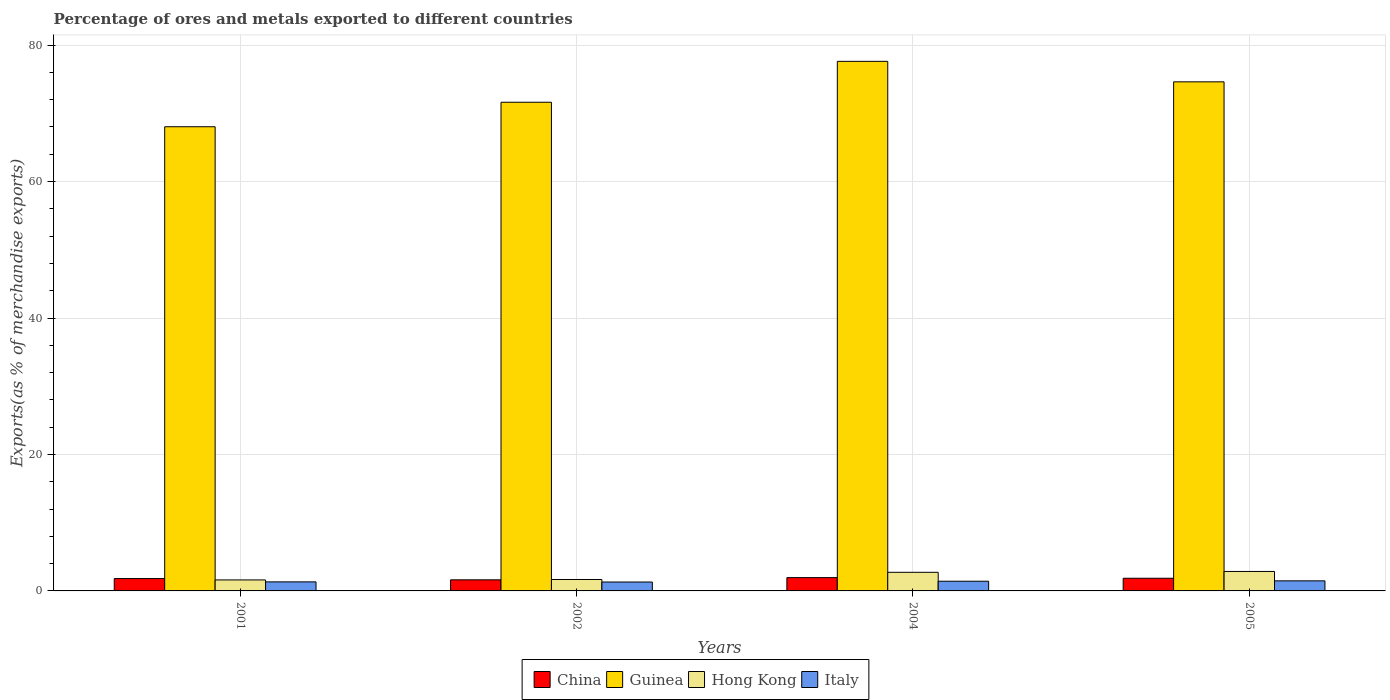How many groups of bars are there?
Offer a terse response. 4. Are the number of bars per tick equal to the number of legend labels?
Your response must be concise. Yes. Are the number of bars on each tick of the X-axis equal?
Make the answer very short. Yes. How many bars are there on the 2nd tick from the right?
Provide a succinct answer. 4. What is the label of the 2nd group of bars from the left?
Give a very brief answer. 2002. What is the percentage of exports to different countries in Guinea in 2004?
Your answer should be very brief. 77.62. Across all years, what is the maximum percentage of exports to different countries in Guinea?
Your answer should be very brief. 77.62. Across all years, what is the minimum percentage of exports to different countries in Italy?
Make the answer very short. 1.3. In which year was the percentage of exports to different countries in China maximum?
Keep it short and to the point. 2004. What is the total percentage of exports to different countries in China in the graph?
Make the answer very short. 7.24. What is the difference between the percentage of exports to different countries in Hong Kong in 2002 and that in 2004?
Provide a short and direct response. -1.05. What is the difference between the percentage of exports to different countries in China in 2001 and the percentage of exports to different countries in Guinea in 2004?
Keep it short and to the point. -75.81. What is the average percentage of exports to different countries in Italy per year?
Give a very brief answer. 1.38. In the year 2005, what is the difference between the percentage of exports to different countries in Hong Kong and percentage of exports to different countries in Guinea?
Your answer should be very brief. -71.76. What is the ratio of the percentage of exports to different countries in Hong Kong in 2001 to that in 2004?
Give a very brief answer. 0.59. What is the difference between the highest and the second highest percentage of exports to different countries in Hong Kong?
Provide a succinct answer. 0.12. What is the difference between the highest and the lowest percentage of exports to different countries in China?
Ensure brevity in your answer.  0.32. Is the sum of the percentage of exports to different countries in Italy in 2004 and 2005 greater than the maximum percentage of exports to different countries in China across all years?
Give a very brief answer. Yes. What does the 1st bar from the right in 2005 represents?
Offer a very short reply. Italy. How many years are there in the graph?
Offer a very short reply. 4. What is the difference between two consecutive major ticks on the Y-axis?
Your answer should be very brief. 20. Does the graph contain any zero values?
Provide a succinct answer. No. Does the graph contain grids?
Provide a succinct answer. Yes. How many legend labels are there?
Offer a very short reply. 4. What is the title of the graph?
Provide a succinct answer. Percentage of ores and metals exported to different countries. Does "Lesotho" appear as one of the legend labels in the graph?
Your response must be concise. No. What is the label or title of the X-axis?
Keep it short and to the point. Years. What is the label or title of the Y-axis?
Make the answer very short. Exports(as % of merchandise exports). What is the Exports(as % of merchandise exports) of China in 2001?
Keep it short and to the point. 1.81. What is the Exports(as % of merchandise exports) in Guinea in 2001?
Your answer should be very brief. 68.03. What is the Exports(as % of merchandise exports) in Hong Kong in 2001?
Keep it short and to the point. 1.61. What is the Exports(as % of merchandise exports) of Italy in 2001?
Offer a terse response. 1.32. What is the Exports(as % of merchandise exports) of China in 2002?
Offer a very short reply. 1.62. What is the Exports(as % of merchandise exports) in Guinea in 2002?
Your response must be concise. 71.63. What is the Exports(as % of merchandise exports) in Hong Kong in 2002?
Your answer should be compact. 1.67. What is the Exports(as % of merchandise exports) of Italy in 2002?
Your answer should be very brief. 1.3. What is the Exports(as % of merchandise exports) of China in 2004?
Your answer should be very brief. 1.95. What is the Exports(as % of merchandise exports) of Guinea in 2004?
Keep it short and to the point. 77.62. What is the Exports(as % of merchandise exports) of Hong Kong in 2004?
Your answer should be very brief. 2.73. What is the Exports(as % of merchandise exports) of Italy in 2004?
Ensure brevity in your answer.  1.42. What is the Exports(as % of merchandise exports) in China in 2005?
Keep it short and to the point. 1.86. What is the Exports(as % of merchandise exports) of Guinea in 2005?
Offer a very short reply. 74.62. What is the Exports(as % of merchandise exports) in Hong Kong in 2005?
Your answer should be compact. 2.85. What is the Exports(as % of merchandise exports) of Italy in 2005?
Ensure brevity in your answer.  1.48. Across all years, what is the maximum Exports(as % of merchandise exports) in China?
Keep it short and to the point. 1.95. Across all years, what is the maximum Exports(as % of merchandise exports) of Guinea?
Your answer should be very brief. 77.62. Across all years, what is the maximum Exports(as % of merchandise exports) of Hong Kong?
Make the answer very short. 2.85. Across all years, what is the maximum Exports(as % of merchandise exports) of Italy?
Provide a short and direct response. 1.48. Across all years, what is the minimum Exports(as % of merchandise exports) in China?
Make the answer very short. 1.62. Across all years, what is the minimum Exports(as % of merchandise exports) of Guinea?
Your answer should be very brief. 68.03. Across all years, what is the minimum Exports(as % of merchandise exports) in Hong Kong?
Your answer should be very brief. 1.61. Across all years, what is the minimum Exports(as % of merchandise exports) in Italy?
Your answer should be compact. 1.3. What is the total Exports(as % of merchandise exports) in China in the graph?
Your answer should be very brief. 7.24. What is the total Exports(as % of merchandise exports) of Guinea in the graph?
Your answer should be very brief. 291.9. What is the total Exports(as % of merchandise exports) in Hong Kong in the graph?
Ensure brevity in your answer.  8.87. What is the total Exports(as % of merchandise exports) of Italy in the graph?
Your answer should be compact. 5.52. What is the difference between the Exports(as % of merchandise exports) of China in 2001 and that in 2002?
Give a very brief answer. 0.19. What is the difference between the Exports(as % of merchandise exports) of Guinea in 2001 and that in 2002?
Make the answer very short. -3.59. What is the difference between the Exports(as % of merchandise exports) of Hong Kong in 2001 and that in 2002?
Offer a terse response. -0.06. What is the difference between the Exports(as % of merchandise exports) of Italy in 2001 and that in 2002?
Provide a short and direct response. 0.02. What is the difference between the Exports(as % of merchandise exports) in China in 2001 and that in 2004?
Keep it short and to the point. -0.14. What is the difference between the Exports(as % of merchandise exports) of Guinea in 2001 and that in 2004?
Provide a short and direct response. -9.58. What is the difference between the Exports(as % of merchandise exports) of Hong Kong in 2001 and that in 2004?
Make the answer very short. -1.12. What is the difference between the Exports(as % of merchandise exports) of Italy in 2001 and that in 2004?
Ensure brevity in your answer.  -0.1. What is the difference between the Exports(as % of merchandise exports) in China in 2001 and that in 2005?
Keep it short and to the point. -0.05. What is the difference between the Exports(as % of merchandise exports) of Guinea in 2001 and that in 2005?
Provide a short and direct response. -6.58. What is the difference between the Exports(as % of merchandise exports) in Hong Kong in 2001 and that in 2005?
Offer a terse response. -1.24. What is the difference between the Exports(as % of merchandise exports) of Italy in 2001 and that in 2005?
Offer a very short reply. -0.15. What is the difference between the Exports(as % of merchandise exports) of China in 2002 and that in 2004?
Your answer should be compact. -0.32. What is the difference between the Exports(as % of merchandise exports) of Guinea in 2002 and that in 2004?
Provide a succinct answer. -5.99. What is the difference between the Exports(as % of merchandise exports) of Hong Kong in 2002 and that in 2004?
Ensure brevity in your answer.  -1.05. What is the difference between the Exports(as % of merchandise exports) of Italy in 2002 and that in 2004?
Keep it short and to the point. -0.12. What is the difference between the Exports(as % of merchandise exports) of China in 2002 and that in 2005?
Provide a succinct answer. -0.23. What is the difference between the Exports(as % of merchandise exports) of Guinea in 2002 and that in 2005?
Your response must be concise. -2.99. What is the difference between the Exports(as % of merchandise exports) of Hong Kong in 2002 and that in 2005?
Give a very brief answer. -1.18. What is the difference between the Exports(as % of merchandise exports) in Italy in 2002 and that in 2005?
Provide a short and direct response. -0.17. What is the difference between the Exports(as % of merchandise exports) of China in 2004 and that in 2005?
Provide a short and direct response. 0.09. What is the difference between the Exports(as % of merchandise exports) of Guinea in 2004 and that in 2005?
Your answer should be compact. 3. What is the difference between the Exports(as % of merchandise exports) in Hong Kong in 2004 and that in 2005?
Offer a terse response. -0.12. What is the difference between the Exports(as % of merchandise exports) in Italy in 2004 and that in 2005?
Keep it short and to the point. -0.05. What is the difference between the Exports(as % of merchandise exports) of China in 2001 and the Exports(as % of merchandise exports) of Guinea in 2002?
Ensure brevity in your answer.  -69.82. What is the difference between the Exports(as % of merchandise exports) of China in 2001 and the Exports(as % of merchandise exports) of Hong Kong in 2002?
Keep it short and to the point. 0.14. What is the difference between the Exports(as % of merchandise exports) of China in 2001 and the Exports(as % of merchandise exports) of Italy in 2002?
Provide a succinct answer. 0.51. What is the difference between the Exports(as % of merchandise exports) of Guinea in 2001 and the Exports(as % of merchandise exports) of Hong Kong in 2002?
Offer a terse response. 66.36. What is the difference between the Exports(as % of merchandise exports) of Guinea in 2001 and the Exports(as % of merchandise exports) of Italy in 2002?
Your answer should be compact. 66.73. What is the difference between the Exports(as % of merchandise exports) in Hong Kong in 2001 and the Exports(as % of merchandise exports) in Italy in 2002?
Offer a terse response. 0.31. What is the difference between the Exports(as % of merchandise exports) in China in 2001 and the Exports(as % of merchandise exports) in Guinea in 2004?
Provide a succinct answer. -75.81. What is the difference between the Exports(as % of merchandise exports) of China in 2001 and the Exports(as % of merchandise exports) of Hong Kong in 2004?
Provide a succinct answer. -0.92. What is the difference between the Exports(as % of merchandise exports) in China in 2001 and the Exports(as % of merchandise exports) in Italy in 2004?
Keep it short and to the point. 0.39. What is the difference between the Exports(as % of merchandise exports) in Guinea in 2001 and the Exports(as % of merchandise exports) in Hong Kong in 2004?
Ensure brevity in your answer.  65.31. What is the difference between the Exports(as % of merchandise exports) of Guinea in 2001 and the Exports(as % of merchandise exports) of Italy in 2004?
Your response must be concise. 66.61. What is the difference between the Exports(as % of merchandise exports) of Hong Kong in 2001 and the Exports(as % of merchandise exports) of Italy in 2004?
Your answer should be compact. 0.19. What is the difference between the Exports(as % of merchandise exports) of China in 2001 and the Exports(as % of merchandise exports) of Guinea in 2005?
Ensure brevity in your answer.  -72.81. What is the difference between the Exports(as % of merchandise exports) in China in 2001 and the Exports(as % of merchandise exports) in Hong Kong in 2005?
Provide a succinct answer. -1.04. What is the difference between the Exports(as % of merchandise exports) in China in 2001 and the Exports(as % of merchandise exports) in Italy in 2005?
Your answer should be compact. 0.34. What is the difference between the Exports(as % of merchandise exports) in Guinea in 2001 and the Exports(as % of merchandise exports) in Hong Kong in 2005?
Offer a very short reply. 65.18. What is the difference between the Exports(as % of merchandise exports) of Guinea in 2001 and the Exports(as % of merchandise exports) of Italy in 2005?
Your response must be concise. 66.56. What is the difference between the Exports(as % of merchandise exports) in Hong Kong in 2001 and the Exports(as % of merchandise exports) in Italy in 2005?
Offer a terse response. 0.14. What is the difference between the Exports(as % of merchandise exports) in China in 2002 and the Exports(as % of merchandise exports) in Guinea in 2004?
Your answer should be compact. -75.99. What is the difference between the Exports(as % of merchandise exports) in China in 2002 and the Exports(as % of merchandise exports) in Hong Kong in 2004?
Make the answer very short. -1.1. What is the difference between the Exports(as % of merchandise exports) of China in 2002 and the Exports(as % of merchandise exports) of Italy in 2004?
Make the answer very short. 0.2. What is the difference between the Exports(as % of merchandise exports) of Guinea in 2002 and the Exports(as % of merchandise exports) of Hong Kong in 2004?
Provide a succinct answer. 68.9. What is the difference between the Exports(as % of merchandise exports) of Guinea in 2002 and the Exports(as % of merchandise exports) of Italy in 2004?
Keep it short and to the point. 70.21. What is the difference between the Exports(as % of merchandise exports) in Hong Kong in 2002 and the Exports(as % of merchandise exports) in Italy in 2004?
Offer a very short reply. 0.25. What is the difference between the Exports(as % of merchandise exports) in China in 2002 and the Exports(as % of merchandise exports) in Guinea in 2005?
Make the answer very short. -72.99. What is the difference between the Exports(as % of merchandise exports) of China in 2002 and the Exports(as % of merchandise exports) of Hong Kong in 2005?
Your answer should be compact. -1.23. What is the difference between the Exports(as % of merchandise exports) in China in 2002 and the Exports(as % of merchandise exports) in Italy in 2005?
Your answer should be very brief. 0.15. What is the difference between the Exports(as % of merchandise exports) in Guinea in 2002 and the Exports(as % of merchandise exports) in Hong Kong in 2005?
Keep it short and to the point. 68.77. What is the difference between the Exports(as % of merchandise exports) of Guinea in 2002 and the Exports(as % of merchandise exports) of Italy in 2005?
Give a very brief answer. 70.15. What is the difference between the Exports(as % of merchandise exports) in Hong Kong in 2002 and the Exports(as % of merchandise exports) in Italy in 2005?
Keep it short and to the point. 0.2. What is the difference between the Exports(as % of merchandise exports) of China in 2004 and the Exports(as % of merchandise exports) of Guinea in 2005?
Keep it short and to the point. -72.67. What is the difference between the Exports(as % of merchandise exports) in China in 2004 and the Exports(as % of merchandise exports) in Hong Kong in 2005?
Your answer should be very brief. -0.9. What is the difference between the Exports(as % of merchandise exports) in China in 2004 and the Exports(as % of merchandise exports) in Italy in 2005?
Your answer should be compact. 0.47. What is the difference between the Exports(as % of merchandise exports) of Guinea in 2004 and the Exports(as % of merchandise exports) of Hong Kong in 2005?
Keep it short and to the point. 74.77. What is the difference between the Exports(as % of merchandise exports) of Guinea in 2004 and the Exports(as % of merchandise exports) of Italy in 2005?
Make the answer very short. 76.14. What is the difference between the Exports(as % of merchandise exports) of Hong Kong in 2004 and the Exports(as % of merchandise exports) of Italy in 2005?
Make the answer very short. 1.25. What is the average Exports(as % of merchandise exports) in China per year?
Your answer should be compact. 1.81. What is the average Exports(as % of merchandise exports) in Guinea per year?
Provide a succinct answer. 72.97. What is the average Exports(as % of merchandise exports) of Hong Kong per year?
Make the answer very short. 2.22. What is the average Exports(as % of merchandise exports) in Italy per year?
Give a very brief answer. 1.38. In the year 2001, what is the difference between the Exports(as % of merchandise exports) of China and Exports(as % of merchandise exports) of Guinea?
Ensure brevity in your answer.  -66.22. In the year 2001, what is the difference between the Exports(as % of merchandise exports) of China and Exports(as % of merchandise exports) of Hong Kong?
Ensure brevity in your answer.  0.2. In the year 2001, what is the difference between the Exports(as % of merchandise exports) of China and Exports(as % of merchandise exports) of Italy?
Keep it short and to the point. 0.49. In the year 2001, what is the difference between the Exports(as % of merchandise exports) of Guinea and Exports(as % of merchandise exports) of Hong Kong?
Make the answer very short. 66.42. In the year 2001, what is the difference between the Exports(as % of merchandise exports) in Guinea and Exports(as % of merchandise exports) in Italy?
Offer a very short reply. 66.71. In the year 2001, what is the difference between the Exports(as % of merchandise exports) of Hong Kong and Exports(as % of merchandise exports) of Italy?
Offer a terse response. 0.29. In the year 2002, what is the difference between the Exports(as % of merchandise exports) in China and Exports(as % of merchandise exports) in Guinea?
Offer a terse response. -70. In the year 2002, what is the difference between the Exports(as % of merchandise exports) in China and Exports(as % of merchandise exports) in Hong Kong?
Provide a short and direct response. -0.05. In the year 2002, what is the difference between the Exports(as % of merchandise exports) in China and Exports(as % of merchandise exports) in Italy?
Your response must be concise. 0.32. In the year 2002, what is the difference between the Exports(as % of merchandise exports) of Guinea and Exports(as % of merchandise exports) of Hong Kong?
Ensure brevity in your answer.  69.95. In the year 2002, what is the difference between the Exports(as % of merchandise exports) of Guinea and Exports(as % of merchandise exports) of Italy?
Ensure brevity in your answer.  70.32. In the year 2002, what is the difference between the Exports(as % of merchandise exports) of Hong Kong and Exports(as % of merchandise exports) of Italy?
Make the answer very short. 0.37. In the year 2004, what is the difference between the Exports(as % of merchandise exports) in China and Exports(as % of merchandise exports) in Guinea?
Provide a short and direct response. -75.67. In the year 2004, what is the difference between the Exports(as % of merchandise exports) of China and Exports(as % of merchandise exports) of Hong Kong?
Your response must be concise. -0.78. In the year 2004, what is the difference between the Exports(as % of merchandise exports) of China and Exports(as % of merchandise exports) of Italy?
Offer a very short reply. 0.53. In the year 2004, what is the difference between the Exports(as % of merchandise exports) of Guinea and Exports(as % of merchandise exports) of Hong Kong?
Your answer should be very brief. 74.89. In the year 2004, what is the difference between the Exports(as % of merchandise exports) of Guinea and Exports(as % of merchandise exports) of Italy?
Offer a terse response. 76.2. In the year 2004, what is the difference between the Exports(as % of merchandise exports) in Hong Kong and Exports(as % of merchandise exports) in Italy?
Offer a terse response. 1.31. In the year 2005, what is the difference between the Exports(as % of merchandise exports) in China and Exports(as % of merchandise exports) in Guinea?
Provide a succinct answer. -72.76. In the year 2005, what is the difference between the Exports(as % of merchandise exports) in China and Exports(as % of merchandise exports) in Hong Kong?
Your answer should be very brief. -1. In the year 2005, what is the difference between the Exports(as % of merchandise exports) in China and Exports(as % of merchandise exports) in Italy?
Ensure brevity in your answer.  0.38. In the year 2005, what is the difference between the Exports(as % of merchandise exports) of Guinea and Exports(as % of merchandise exports) of Hong Kong?
Give a very brief answer. 71.76. In the year 2005, what is the difference between the Exports(as % of merchandise exports) of Guinea and Exports(as % of merchandise exports) of Italy?
Provide a succinct answer. 73.14. In the year 2005, what is the difference between the Exports(as % of merchandise exports) of Hong Kong and Exports(as % of merchandise exports) of Italy?
Make the answer very short. 1.38. What is the ratio of the Exports(as % of merchandise exports) of China in 2001 to that in 2002?
Offer a very short reply. 1.11. What is the ratio of the Exports(as % of merchandise exports) in Guinea in 2001 to that in 2002?
Give a very brief answer. 0.95. What is the ratio of the Exports(as % of merchandise exports) of Hong Kong in 2001 to that in 2002?
Your response must be concise. 0.96. What is the ratio of the Exports(as % of merchandise exports) of Italy in 2001 to that in 2002?
Give a very brief answer. 1.02. What is the ratio of the Exports(as % of merchandise exports) in China in 2001 to that in 2004?
Your answer should be very brief. 0.93. What is the ratio of the Exports(as % of merchandise exports) in Guinea in 2001 to that in 2004?
Keep it short and to the point. 0.88. What is the ratio of the Exports(as % of merchandise exports) in Hong Kong in 2001 to that in 2004?
Ensure brevity in your answer.  0.59. What is the ratio of the Exports(as % of merchandise exports) in Italy in 2001 to that in 2004?
Give a very brief answer. 0.93. What is the ratio of the Exports(as % of merchandise exports) in China in 2001 to that in 2005?
Make the answer very short. 0.98. What is the ratio of the Exports(as % of merchandise exports) in Guinea in 2001 to that in 2005?
Give a very brief answer. 0.91. What is the ratio of the Exports(as % of merchandise exports) of Hong Kong in 2001 to that in 2005?
Ensure brevity in your answer.  0.56. What is the ratio of the Exports(as % of merchandise exports) in Italy in 2001 to that in 2005?
Provide a short and direct response. 0.9. What is the ratio of the Exports(as % of merchandise exports) of China in 2002 to that in 2004?
Provide a succinct answer. 0.83. What is the ratio of the Exports(as % of merchandise exports) of Guinea in 2002 to that in 2004?
Offer a very short reply. 0.92. What is the ratio of the Exports(as % of merchandise exports) of Hong Kong in 2002 to that in 2004?
Make the answer very short. 0.61. What is the ratio of the Exports(as % of merchandise exports) of Italy in 2002 to that in 2004?
Make the answer very short. 0.92. What is the ratio of the Exports(as % of merchandise exports) in China in 2002 to that in 2005?
Your answer should be compact. 0.88. What is the ratio of the Exports(as % of merchandise exports) in Guinea in 2002 to that in 2005?
Make the answer very short. 0.96. What is the ratio of the Exports(as % of merchandise exports) of Hong Kong in 2002 to that in 2005?
Provide a short and direct response. 0.59. What is the ratio of the Exports(as % of merchandise exports) of Italy in 2002 to that in 2005?
Your answer should be very brief. 0.88. What is the ratio of the Exports(as % of merchandise exports) in Guinea in 2004 to that in 2005?
Offer a very short reply. 1.04. What is the ratio of the Exports(as % of merchandise exports) of Hong Kong in 2004 to that in 2005?
Provide a short and direct response. 0.96. What is the ratio of the Exports(as % of merchandise exports) of Italy in 2004 to that in 2005?
Give a very brief answer. 0.96. What is the difference between the highest and the second highest Exports(as % of merchandise exports) of China?
Your answer should be very brief. 0.09. What is the difference between the highest and the second highest Exports(as % of merchandise exports) of Guinea?
Offer a terse response. 3. What is the difference between the highest and the second highest Exports(as % of merchandise exports) in Hong Kong?
Ensure brevity in your answer.  0.12. What is the difference between the highest and the second highest Exports(as % of merchandise exports) in Italy?
Offer a terse response. 0.05. What is the difference between the highest and the lowest Exports(as % of merchandise exports) of China?
Your answer should be compact. 0.32. What is the difference between the highest and the lowest Exports(as % of merchandise exports) of Guinea?
Provide a short and direct response. 9.58. What is the difference between the highest and the lowest Exports(as % of merchandise exports) of Hong Kong?
Offer a terse response. 1.24. What is the difference between the highest and the lowest Exports(as % of merchandise exports) in Italy?
Give a very brief answer. 0.17. 